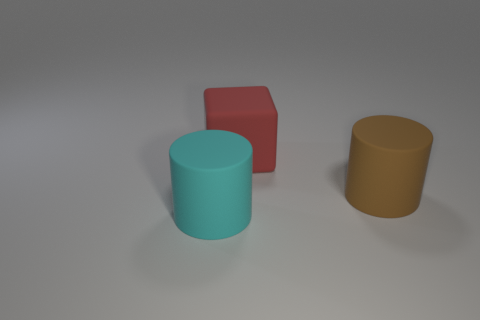What materials do the objects in the image appear to be made from? The objects in the image seem to have different textures. The blue and the brown objects appear to have a matte, possibly plastic or rubber texture, while the red object has a smoother, possibly metallic texture. 